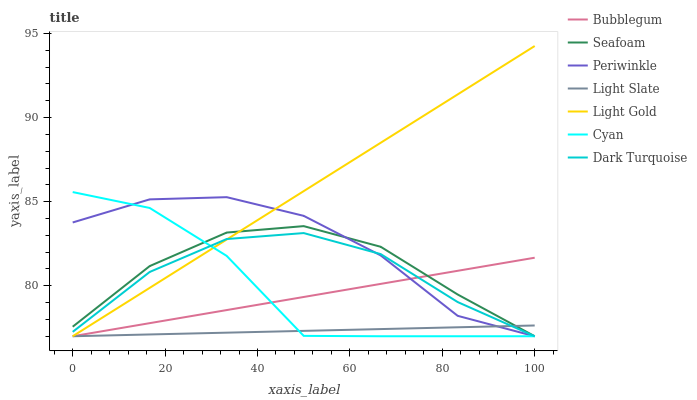Does Light Slate have the minimum area under the curve?
Answer yes or no. Yes. Does Light Gold have the maximum area under the curve?
Answer yes or no. Yes. Does Dark Turquoise have the minimum area under the curve?
Answer yes or no. No. Does Dark Turquoise have the maximum area under the curve?
Answer yes or no. No. Is Light Gold the smoothest?
Answer yes or no. Yes. Is Cyan the roughest?
Answer yes or no. Yes. Is Dark Turquoise the smoothest?
Answer yes or no. No. Is Dark Turquoise the roughest?
Answer yes or no. No. Does Light Slate have the lowest value?
Answer yes or no. Yes. Does Light Gold have the highest value?
Answer yes or no. Yes. Does Dark Turquoise have the highest value?
Answer yes or no. No. Does Cyan intersect Seafoam?
Answer yes or no. Yes. Is Cyan less than Seafoam?
Answer yes or no. No. Is Cyan greater than Seafoam?
Answer yes or no. No. 